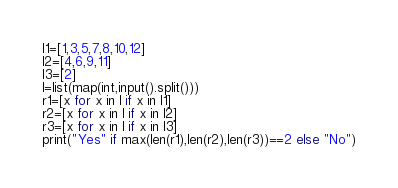Convert code to text. <code><loc_0><loc_0><loc_500><loc_500><_Python_>l1=[1,3,5,7,8,10,12]
l2=[4,6,9,11]
l3=[2]
l=list(map(int,input().split()))
r1=[x for x in l if x in l1]
r2=[x for x in l if x in l2]
r3=[x for x in l if x in l3]
print("Yes" if max(len(r1),len(r2),len(r3))==2 else "No")</code> 